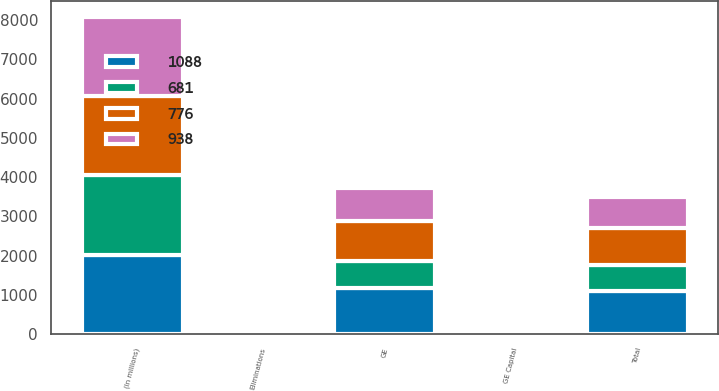Convert chart to OTSL. <chart><loc_0><loc_0><loc_500><loc_500><stacked_bar_chart><ecel><fcel>(In millions)<fcel>GE<fcel>GE Capital<fcel>Eliminations<fcel>Total<nl><fcel>1088<fcel>2019<fcel>1162<fcel>29<fcel>103<fcel>1088<nl><fcel>776<fcel>2020<fcel>1010<fcel>27<fcel>99<fcel>938<nl><fcel>938<fcel>2021<fcel>844<fcel>27<fcel>95<fcel>776<nl><fcel>681<fcel>2022<fcel>707<fcel>59<fcel>85<fcel>681<nl></chart> 